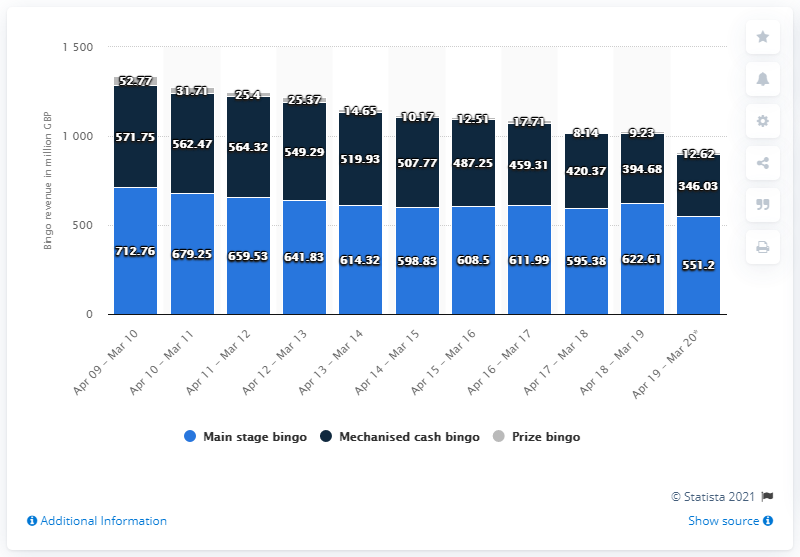Highlight a few significant elements in this photo. Bingo's revenue from April 2019 to March 2020 was 551.2 million dollars. 